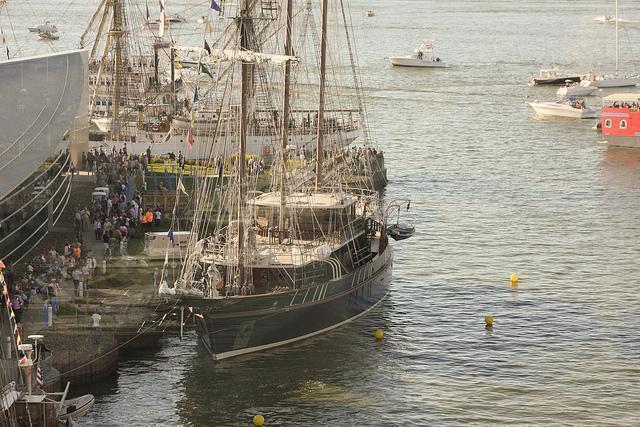What century of advancement might this boat belong to?
Indicate the correct response by choosing from the four available options to answer the question.
Options: 20th, 19th, 21st, 18th. 18th. How many sail posts are on the back of this historic sailing ship?
Choose the right answer from the provided options to respond to the question.
Options: Four, three, five, two. Three. 